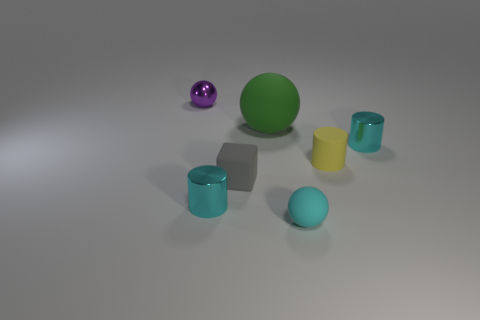How many metallic things are the same color as the small rubber ball?
Your response must be concise. 2. Is the size of the cyan thing that is on the right side of the small cyan rubber ball the same as the matte cylinder that is on the right side of the rubber cube?
Make the answer very short. Yes. There is a rubber sphere behind the tiny shiny cylinder right of the matte ball behind the cyan rubber ball; what is its color?
Offer a very short reply. Green. Are there any red rubber objects that have the same shape as the tiny yellow rubber object?
Your answer should be compact. No. Are there an equal number of tiny cyan things that are right of the tiny yellow cylinder and big green objects that are right of the cube?
Keep it short and to the point. Yes. There is a small cyan object that is behind the small cube; does it have the same shape as the tiny yellow object?
Provide a short and direct response. Yes. Is the tiny yellow matte object the same shape as the cyan rubber thing?
Keep it short and to the point. No. How many matte things are either cylinders or tiny cyan objects?
Make the answer very short. 2. Do the gray rubber cube and the purple ball have the same size?
Ensure brevity in your answer.  Yes. What number of things are either large brown objects or metallic cylinders on the right side of the small rubber block?
Offer a very short reply. 1. 